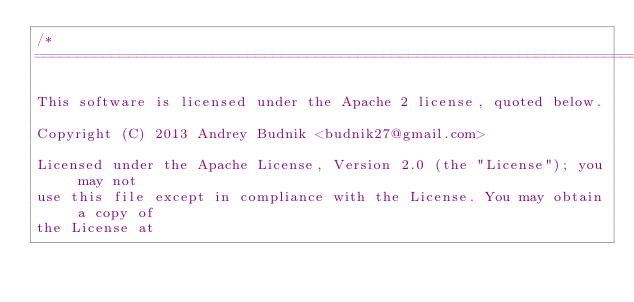<code> <loc_0><loc_0><loc_500><loc_500><_C_>/*
===========================================================================

This software is licensed under the Apache 2 license, quoted below.

Copyright (C) 2013 Andrey Budnik <budnik27@gmail.com>

Licensed under the Apache License, Version 2.0 (the "License"); you may not
use this file except in compliance with the License. You may obtain a copy of
the License at
</code> 